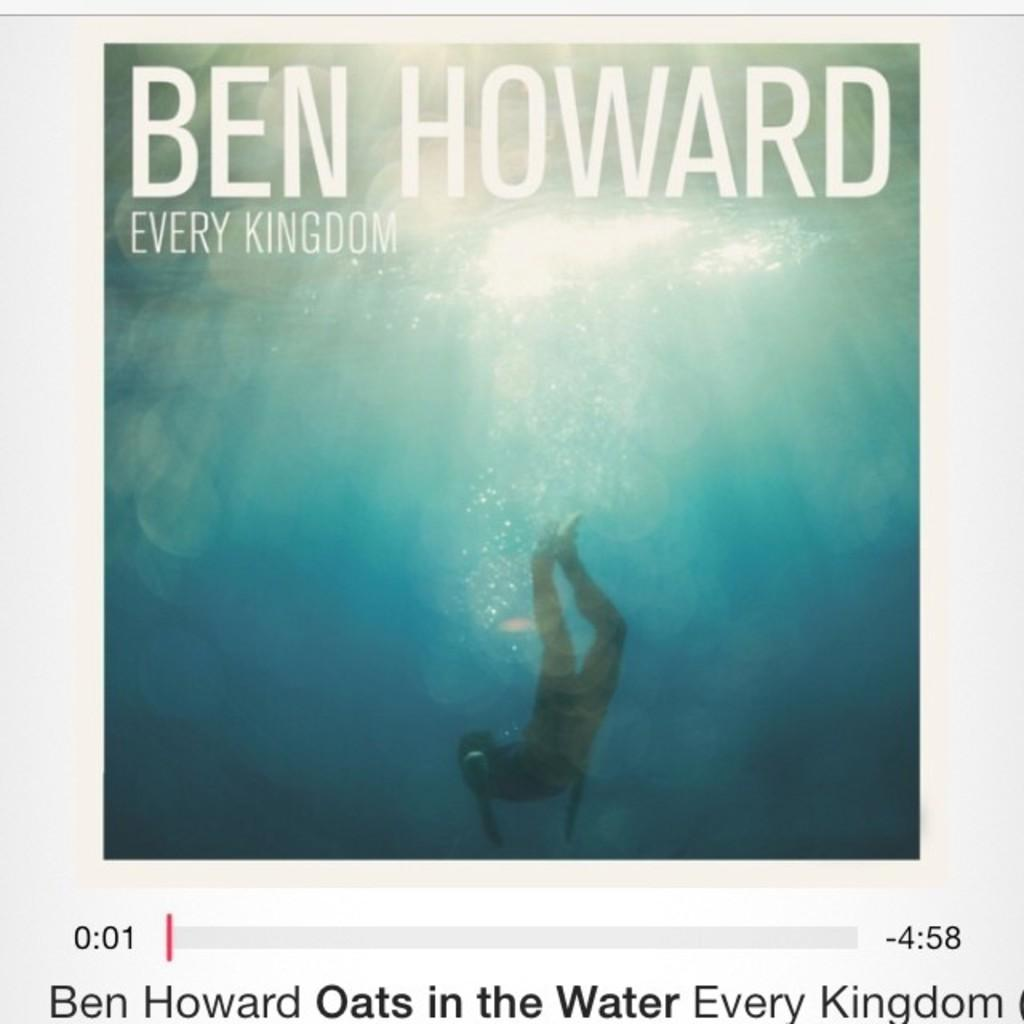<image>
Describe the image concisely. An album cover for Ben Howard called every kingdom. 